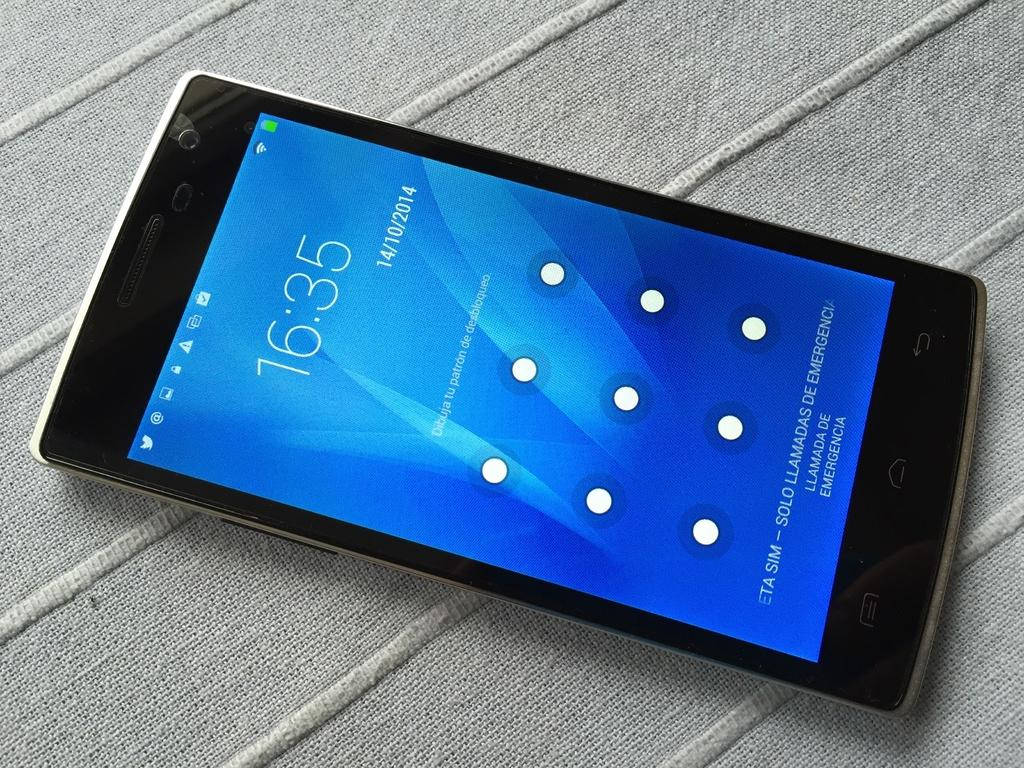Provide a one-sentence caption for the provided image. A product shot of a cell phone showing the blue lock screen and the time 16:35. 